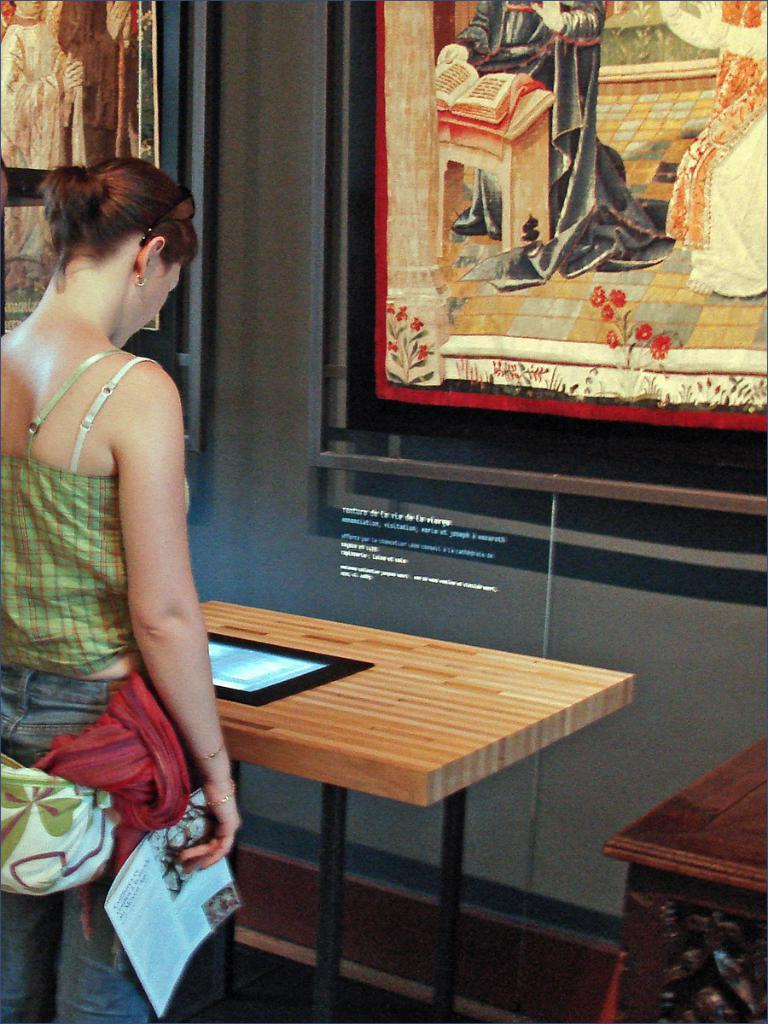Who is the main subject on the left side of the image? There is a lady standing on the left side of the image. What is the lady holding in her hand? The lady is holding a paper in her hand. What objects are in front of the lady? There are tables in front of the lady. What can be seen on the wall in the image? Wall frames are placed on the wall. Can you see a carriage in the image? There is no carriage present in the image. Are the wall frames kissing each other in the image? The wall frames are not kissing each other; they are simply placed on the wall. 